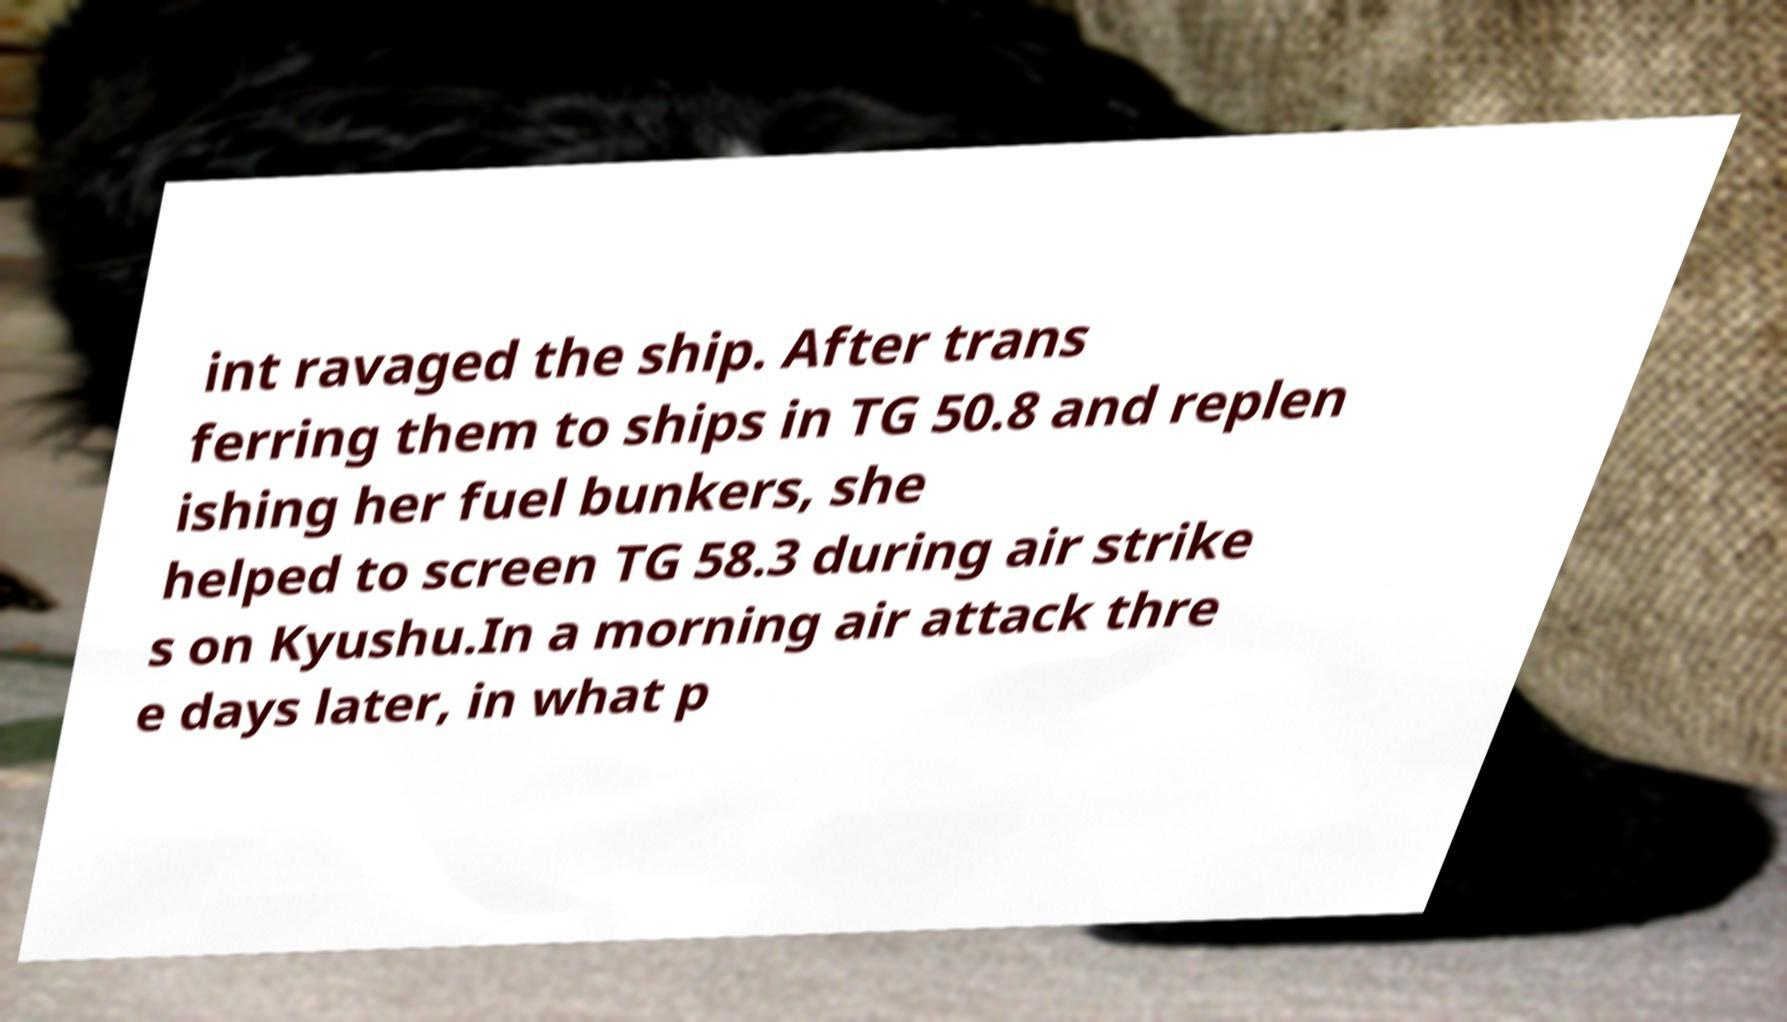Please identify and transcribe the text found in this image. int ravaged the ship. After trans ferring them to ships in TG 50.8 and replen ishing her fuel bunkers, she helped to screen TG 58.3 during air strike s on Kyushu.In a morning air attack thre e days later, in what p 